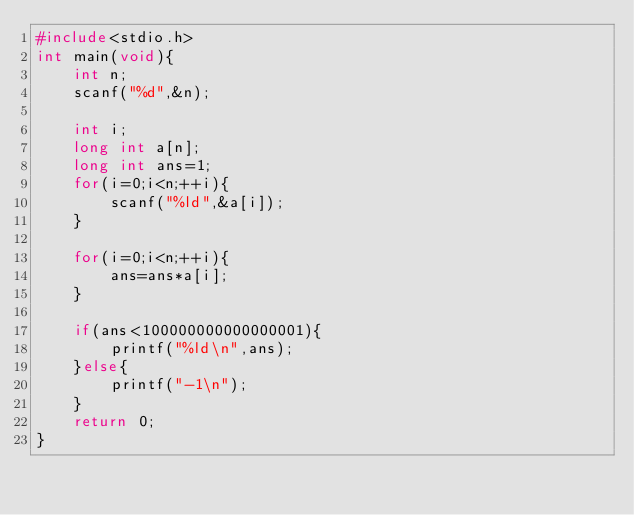<code> <loc_0><loc_0><loc_500><loc_500><_C_>#include<stdio.h>
int main(void){
    int n;
    scanf("%d",&n);

    int i;
    long int a[n];
    long int ans=1;
    for(i=0;i<n;++i){
        scanf("%ld",&a[i]);
    }

    for(i=0;i<n;++i){
        ans=ans*a[i];
    }

    if(ans<100000000000000001){
        printf("%ld\n",ans);
    }else{
        printf("-1\n");
    }
    return 0;
}</code> 